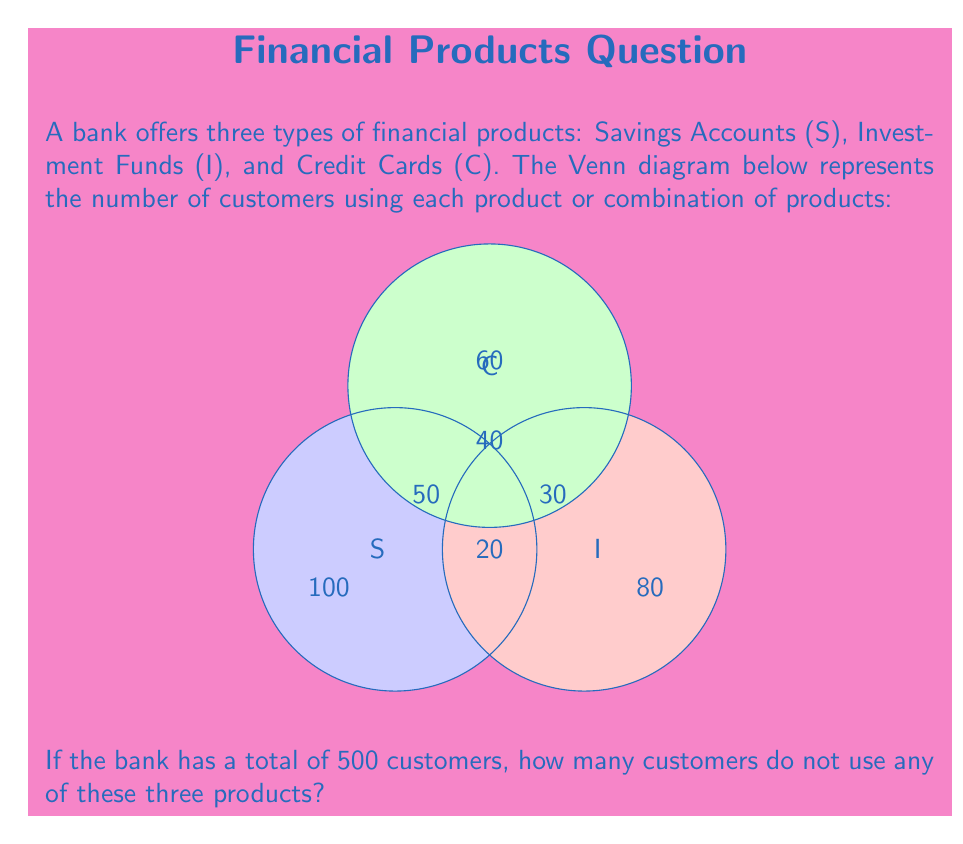Give your solution to this math problem. Let's solve this step-by-step using the given Venn diagram:

1) First, let's calculate the total number of customers using at least one of these products:
   
   $$S \cup I \cup C = 100 + 80 + 60 + 50 + 30 + 40 + 20 = 380$$

2) Now, we know that the bank has a total of 500 customers. To find the number of customers not using any of these products, we subtract the number of customers using at least one product from the total:

   $$\text{Customers not using any product} = \text{Total customers} - (S \cup I \cup C)$$
   $$= 500 - 380 = 120$$

Therefore, 120 customers do not use any of these three products.
Answer: 120 customers 